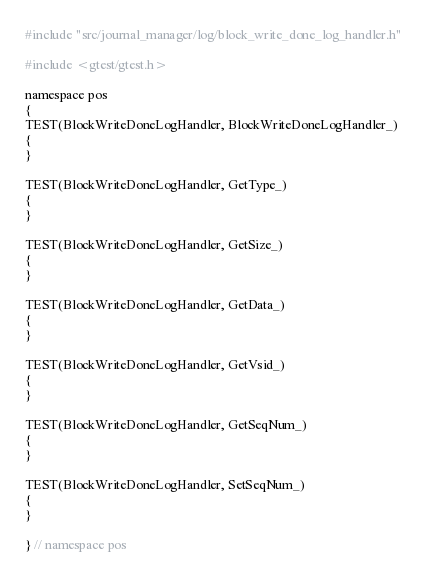Convert code to text. <code><loc_0><loc_0><loc_500><loc_500><_C++_>#include "src/journal_manager/log/block_write_done_log_handler.h"

#include <gtest/gtest.h>

namespace pos
{
TEST(BlockWriteDoneLogHandler, BlockWriteDoneLogHandler_)
{
}

TEST(BlockWriteDoneLogHandler, GetType_)
{
}

TEST(BlockWriteDoneLogHandler, GetSize_)
{
}

TEST(BlockWriteDoneLogHandler, GetData_)
{
}

TEST(BlockWriteDoneLogHandler, GetVsid_)
{
}

TEST(BlockWriteDoneLogHandler, GetSeqNum_)
{
}

TEST(BlockWriteDoneLogHandler, SetSeqNum_)
{
}

} // namespace pos
</code> 